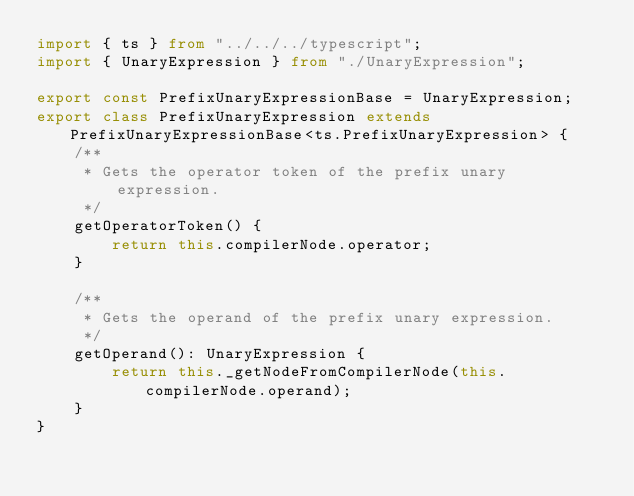<code> <loc_0><loc_0><loc_500><loc_500><_TypeScript_>import { ts } from "../../../typescript";
import { UnaryExpression } from "./UnaryExpression";

export const PrefixUnaryExpressionBase = UnaryExpression;
export class PrefixUnaryExpression extends PrefixUnaryExpressionBase<ts.PrefixUnaryExpression> {
    /**
     * Gets the operator token of the prefix unary expression.
     */
    getOperatorToken() {
        return this.compilerNode.operator;
    }

    /**
     * Gets the operand of the prefix unary expression.
     */
    getOperand(): UnaryExpression {
        return this._getNodeFromCompilerNode(this.compilerNode.operand);
    }
}
</code> 